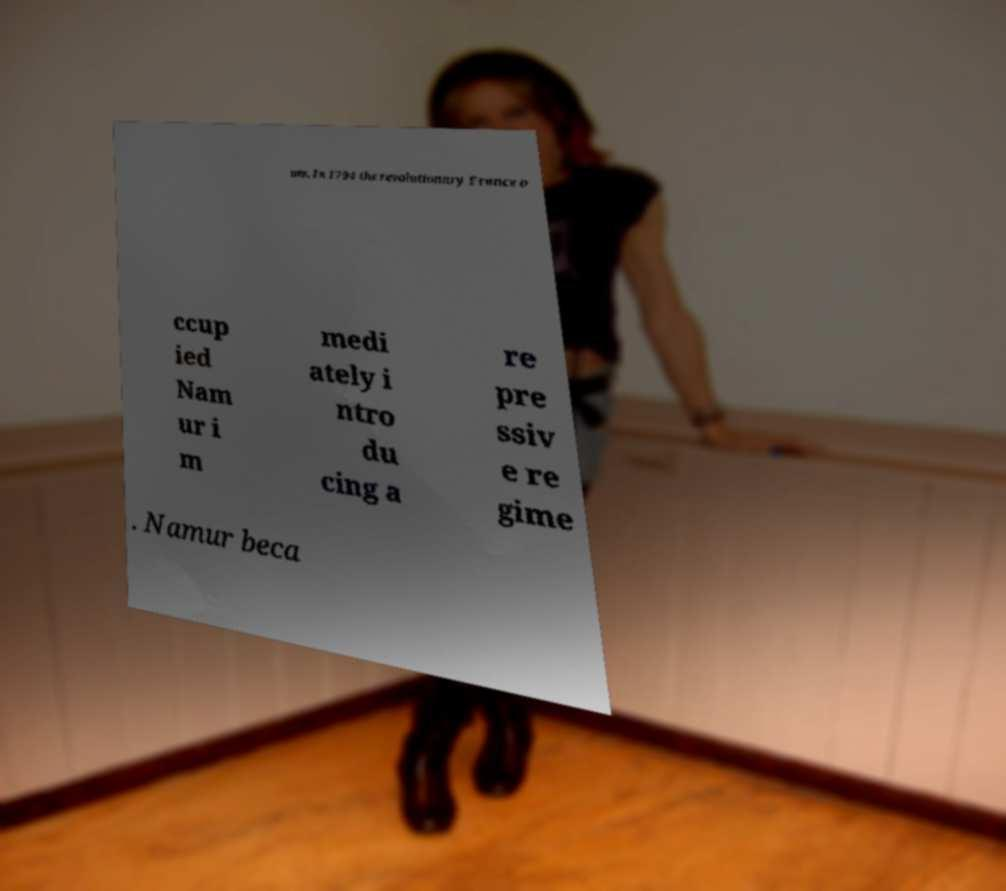Can you read and provide the text displayed in the image?This photo seems to have some interesting text. Can you extract and type it out for me? um. In 1794 the revolutionary France o ccup ied Nam ur i m medi ately i ntro du cing a re pre ssiv e re gime . Namur beca 